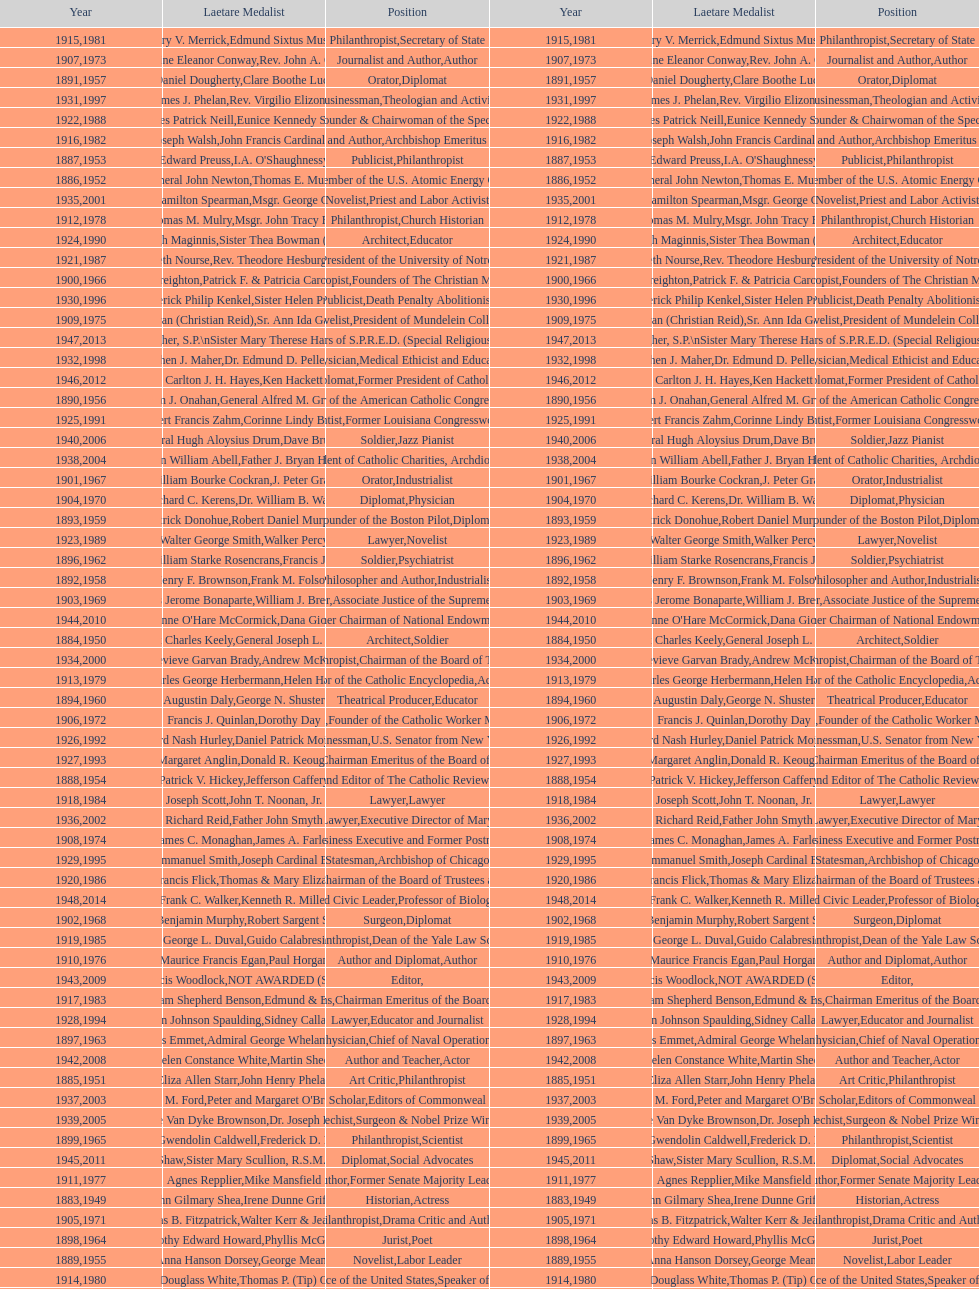What are the total number of times soldier is listed as the position on this chart? 4. 